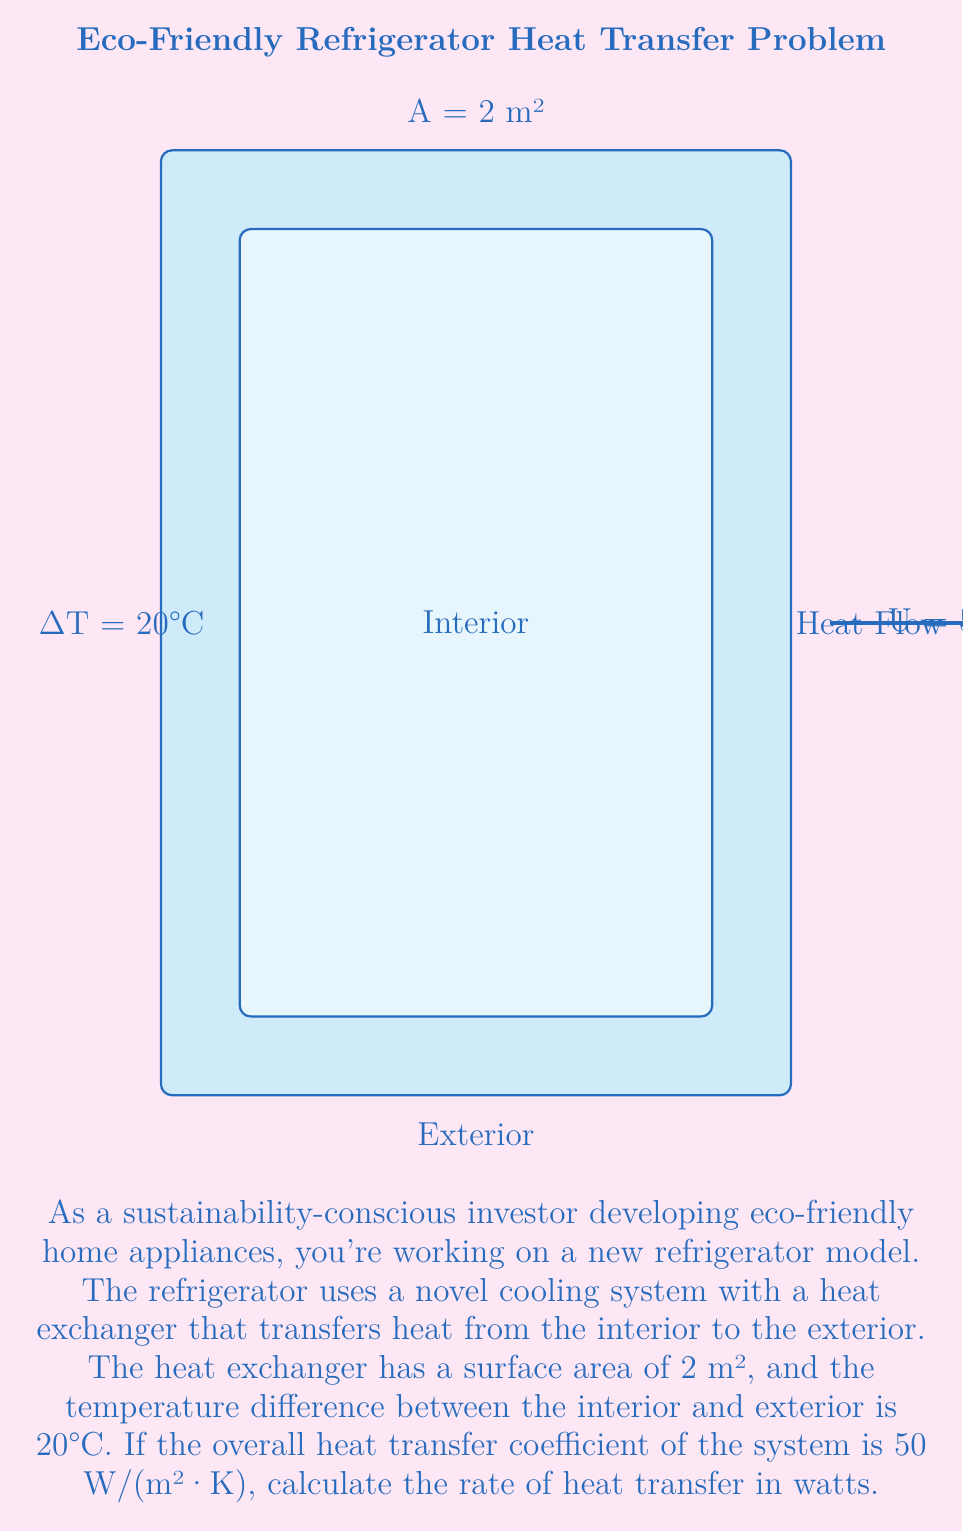Can you solve this math problem? To solve this problem, we'll use the heat transfer equation:

$$Q = U \cdot A \cdot \Delta T$$

Where:
- $Q$ is the rate of heat transfer (in watts, W)
- $U$ is the overall heat transfer coefficient (in W/(m²·K))
- $A$ is the surface area of the heat exchanger (in m²)
- $\Delta T$ is the temperature difference (in K or °C)

Given:
- $U = 50$ W/(m²·K)
- $A = 2$ m²
- $\Delta T = 20°C$

Step 1: Substitute the values into the equation:

$$Q = 50 \frac{W}{m^2 \cdot K} \cdot 2 m^2 \cdot 20 K$$

Step 2: Multiply the values:

$$Q = 50 \cdot 2 \cdot 20 = 2000 W$$

Therefore, the rate of heat transfer is 2000 watts or 2 kilowatts.
Answer: 2000 W 